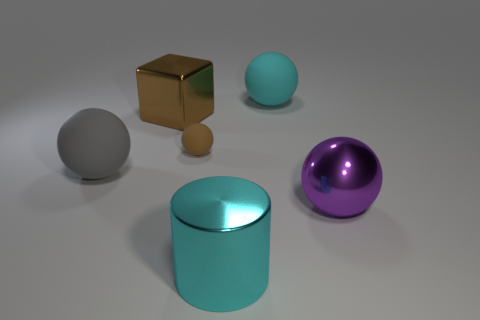Is there a big sphere of the same color as the big metal block?
Provide a succinct answer. No. What number of things are either rubber objects behind the brown shiny cube or balls that are to the left of the cyan matte object?
Give a very brief answer. 3. There is a large rubber ball behind the gray matte thing; are there any large gray matte objects that are to the right of it?
Give a very brief answer. No. There is a cyan shiny thing that is the same size as the brown cube; what is its shape?
Your answer should be very brief. Cylinder. How many things are objects right of the large cyan shiny cylinder or large brown spheres?
Make the answer very short. 2. There is another object that is the same color as the tiny thing; what is its shape?
Give a very brief answer. Cube. How big is the matte ball on the left side of the brown metal block?
Keep it short and to the point. Large. What shape is the brown object that is the same material as the large purple thing?
Provide a short and direct response. Cube. Is the material of the big block the same as the large cyan object that is in front of the large cube?
Your answer should be very brief. Yes. There is a shiny thing to the left of the brown rubber ball; does it have the same shape as the big cyan matte thing?
Offer a terse response. No. 